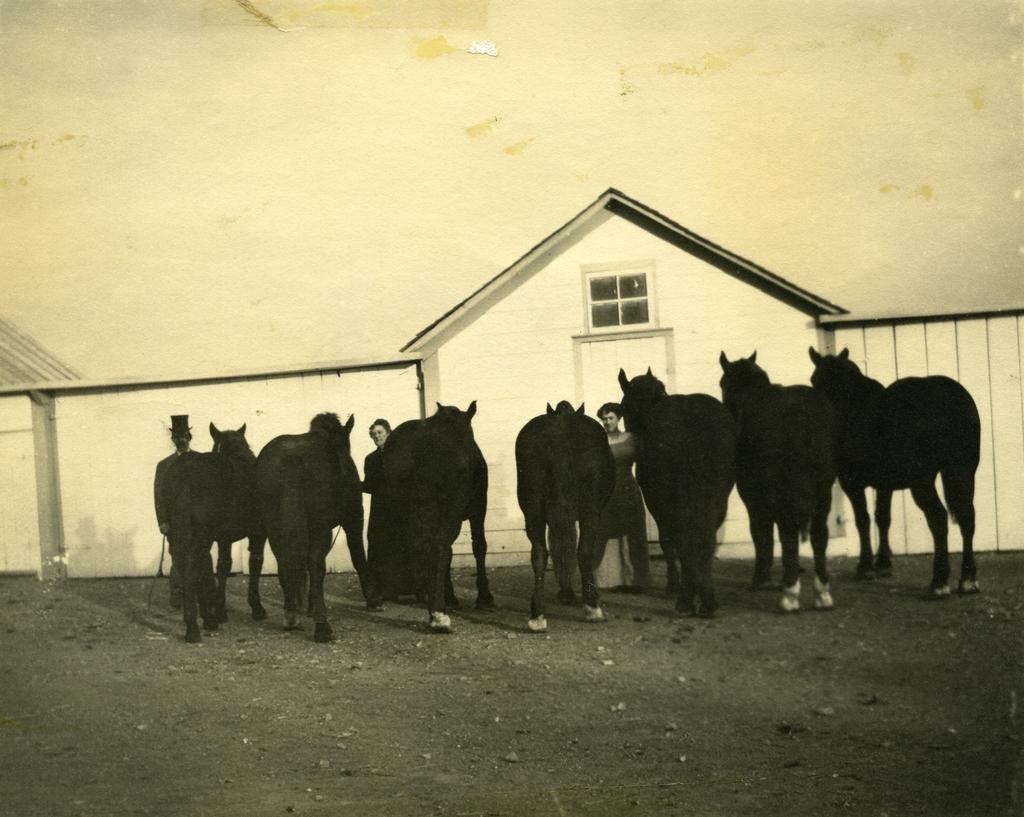How would you summarize this image in a sentence or two? There are three person and animals. They are holding a animals. We can see in the background wall,door and window. 